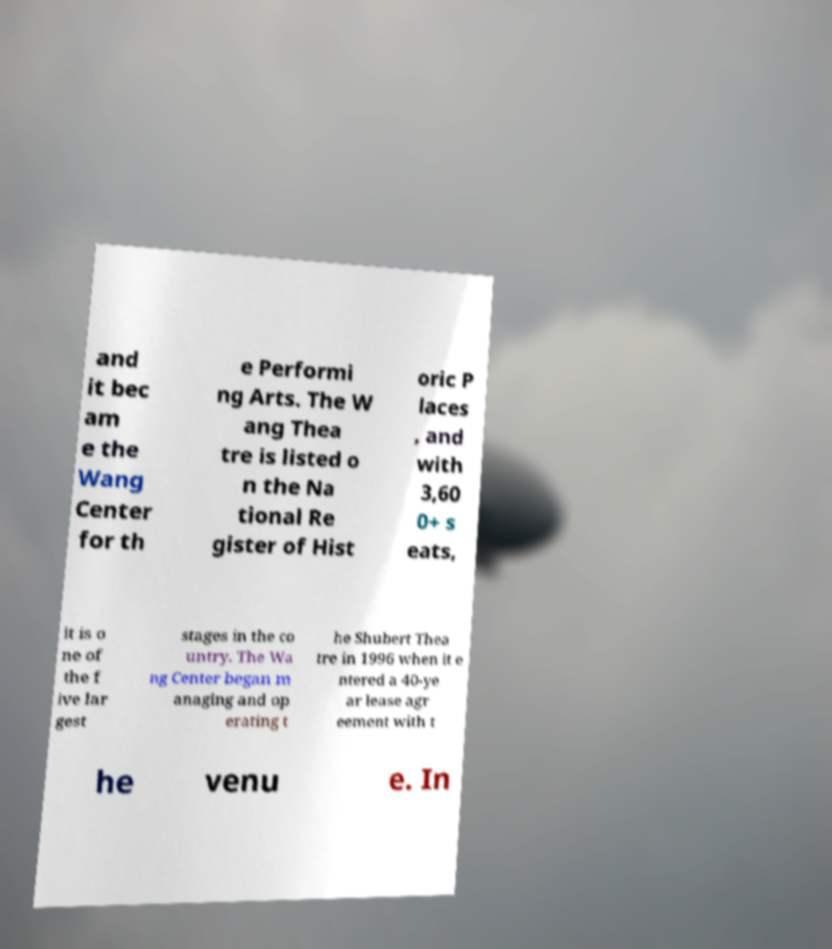Could you assist in decoding the text presented in this image and type it out clearly? and it bec am e the Wang Center for th e Performi ng Arts. The W ang Thea tre is listed o n the Na tional Re gister of Hist oric P laces , and with 3,60 0+ s eats, it is o ne of the f ive lar gest stages in the co untry. The Wa ng Center began m anaging and op erating t he Shubert Thea tre in 1996 when it e ntered a 40-ye ar lease agr eement with t he venu e. In 